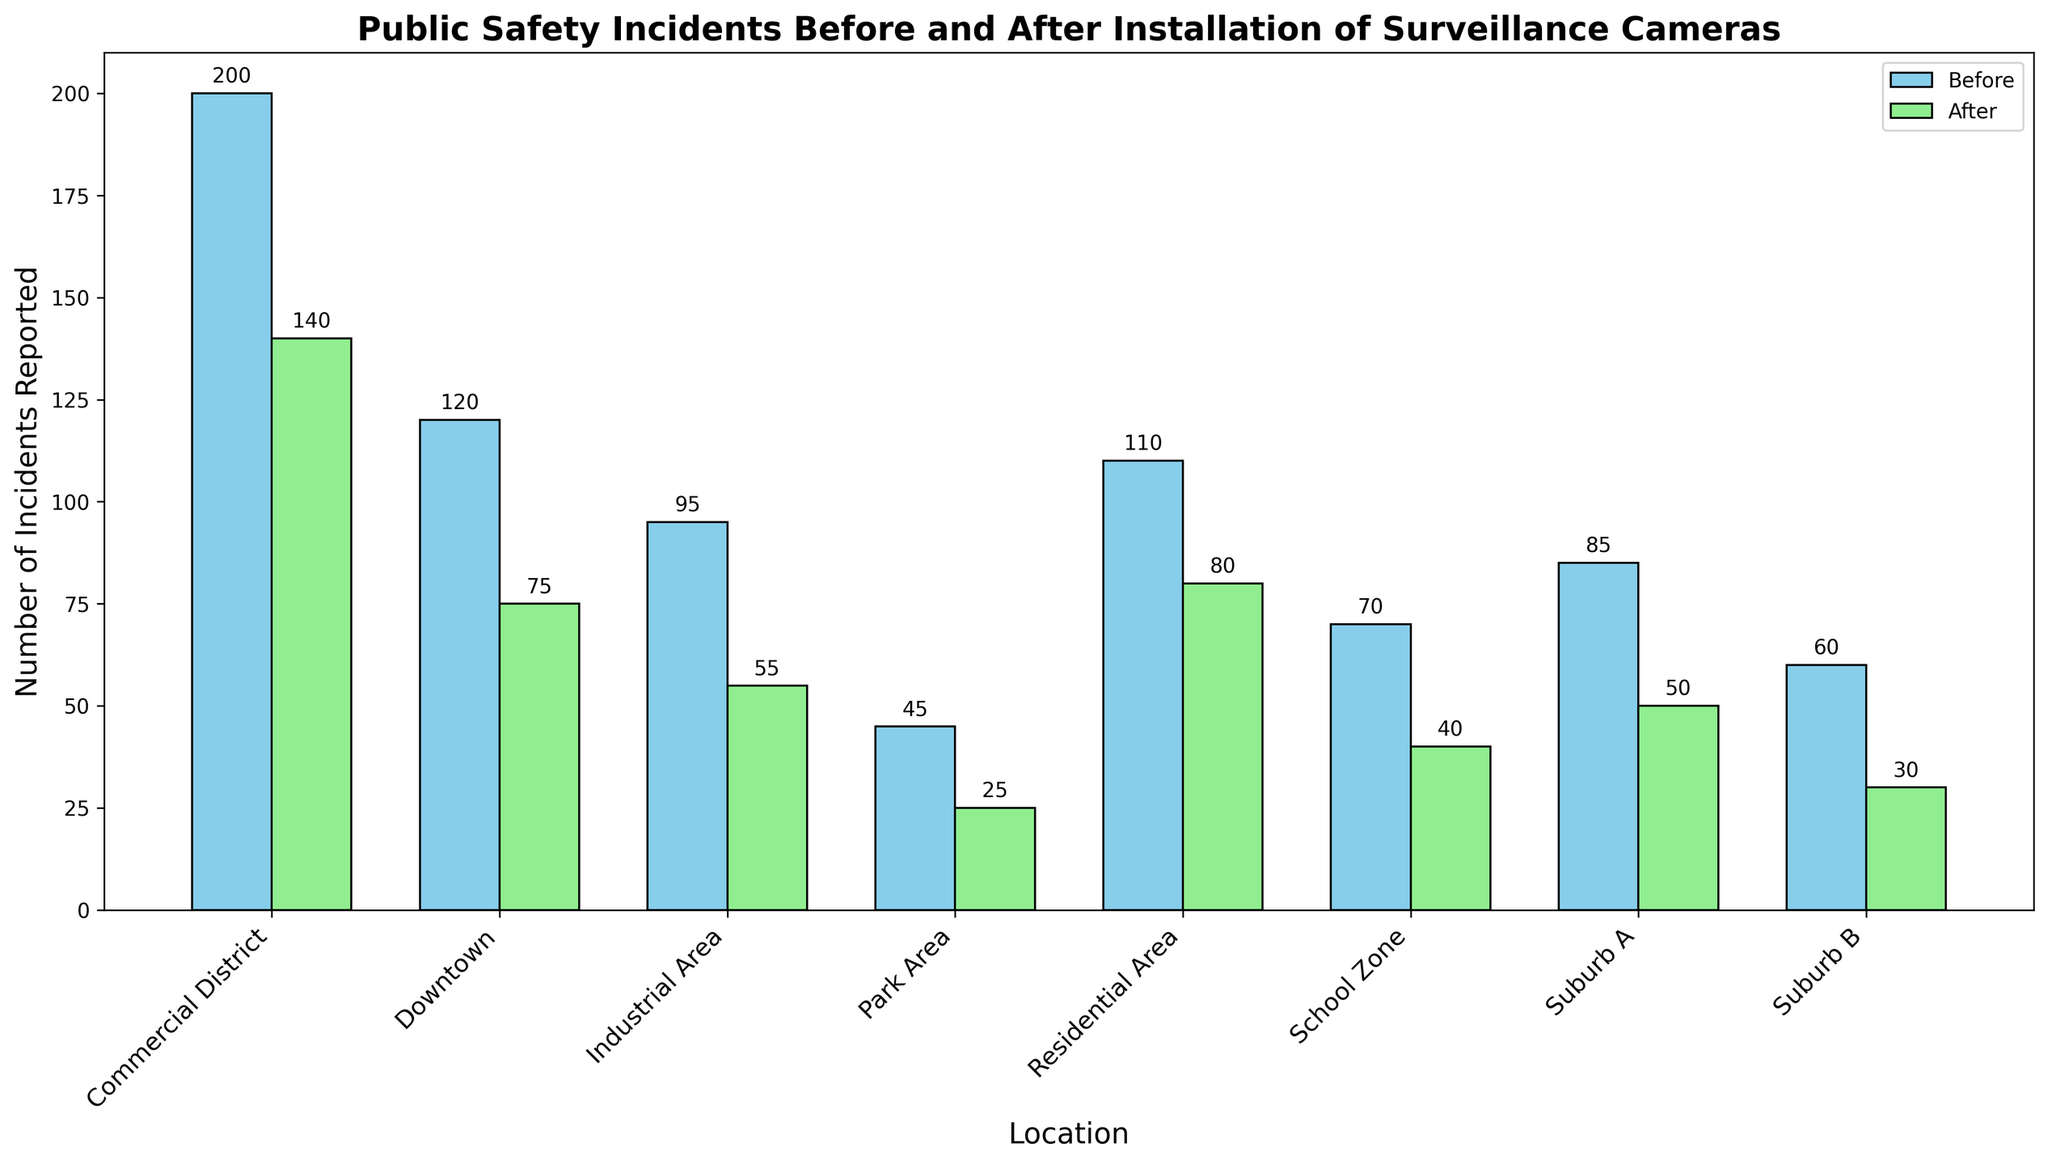Which location had the highest number of incidents reported before the installation of surveillance cameras? By analyzing the heights of the blue bars for each location, we can see that the Commercial District has the tallest bar, indicating the highest number of incidents (200) reported before the installation.
Answer: Commercial District How many fewer incidents were reported in Suburb A after the installation of surveillance cameras? We can find this by subtracting the height of the green bar (50) from the height of the blue bar (85) for Suburb A. Thus, 85 - 50 = 35 fewer incidents were reported.
Answer: 35 What's the difference in the sum of incidents reported before and after the installation of surveillance cameras in Downtown and Park Area combined? Calculate the before and after sums for both locations: Downtown: 120 (Before) + 75 (After) = 195, Park Area: 45 (Before) + 25 (After) = 70. The difference is (120 + 45) - (75 + 25) = 195 - 100 = 95.
Answer: 95 Which location had the greatest decrease in incidents reported after surveillance cameras were installed? Determine this by identifying the biggest difference in height between the blue and green bars. The Commercial District had the largest decrease: 200 (Before) - 140 (After) = 60 fewer incidents.
Answer: Commercial District Did any location have an equal number of incidents reported before and after the installation of surveillance cameras? Compare the heights of the blue and green bars for each location. No location has bars of equal height, so no locations reported the same number of incidents before and after.
Answer: No Which locations had fewer incidents reported after the installation of surveillance cameras compared to before? Observing the green bars being shorter than the blue bars, all locations show a decrease in incidents after the installation. These locations are Downtown, Suburb A, Suburb B, Commercial District, Industrial Area, Residential Area, Park Area, and School Zone.
Answer: All locations What is the average number of incidents reported after the installation of surveillance cameras in Residential Area and Suburb B? To find the average, sum the number of incidents reported after for both locations: Residential Area: 80, Suburb B: 30. Then, (80 + 30) / 2 = 55.
Answer: 55 In which location did the number of incidents reported drop below 30 after the installation of surveillance cameras? Identify green bars that are below the 30 mark on the y-axis. Only Suburb B had incidents drop below 30, reporting exactly 30 incidents after the installation.
Answer: Suburb B 